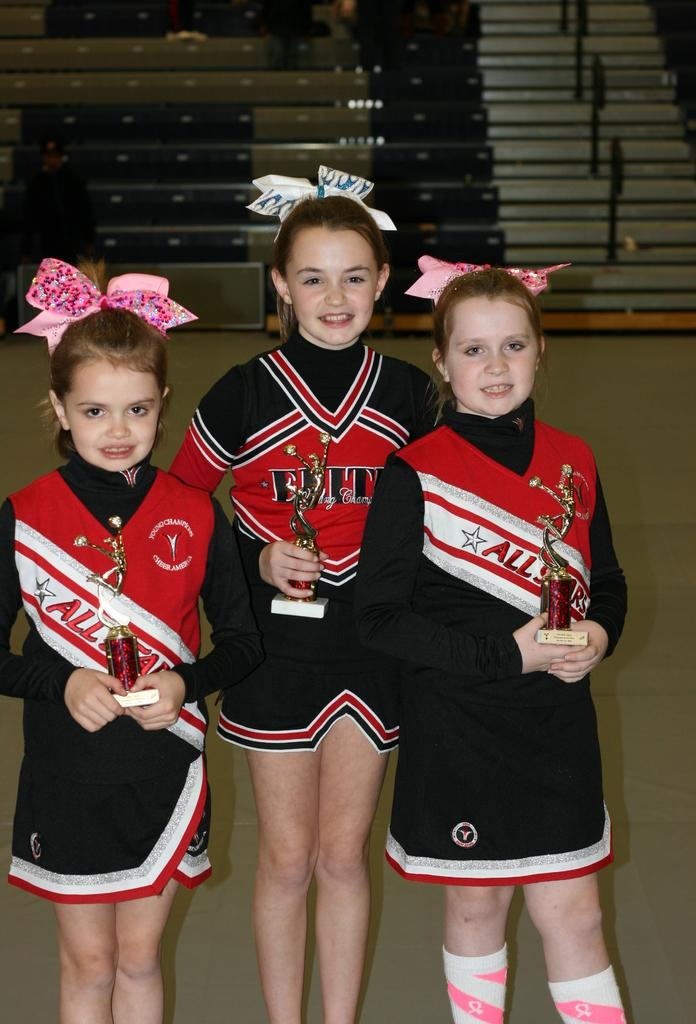<image>
Create a compact narrative representing the image presented. The uniforms for the cheerleaders says All Star on the front 